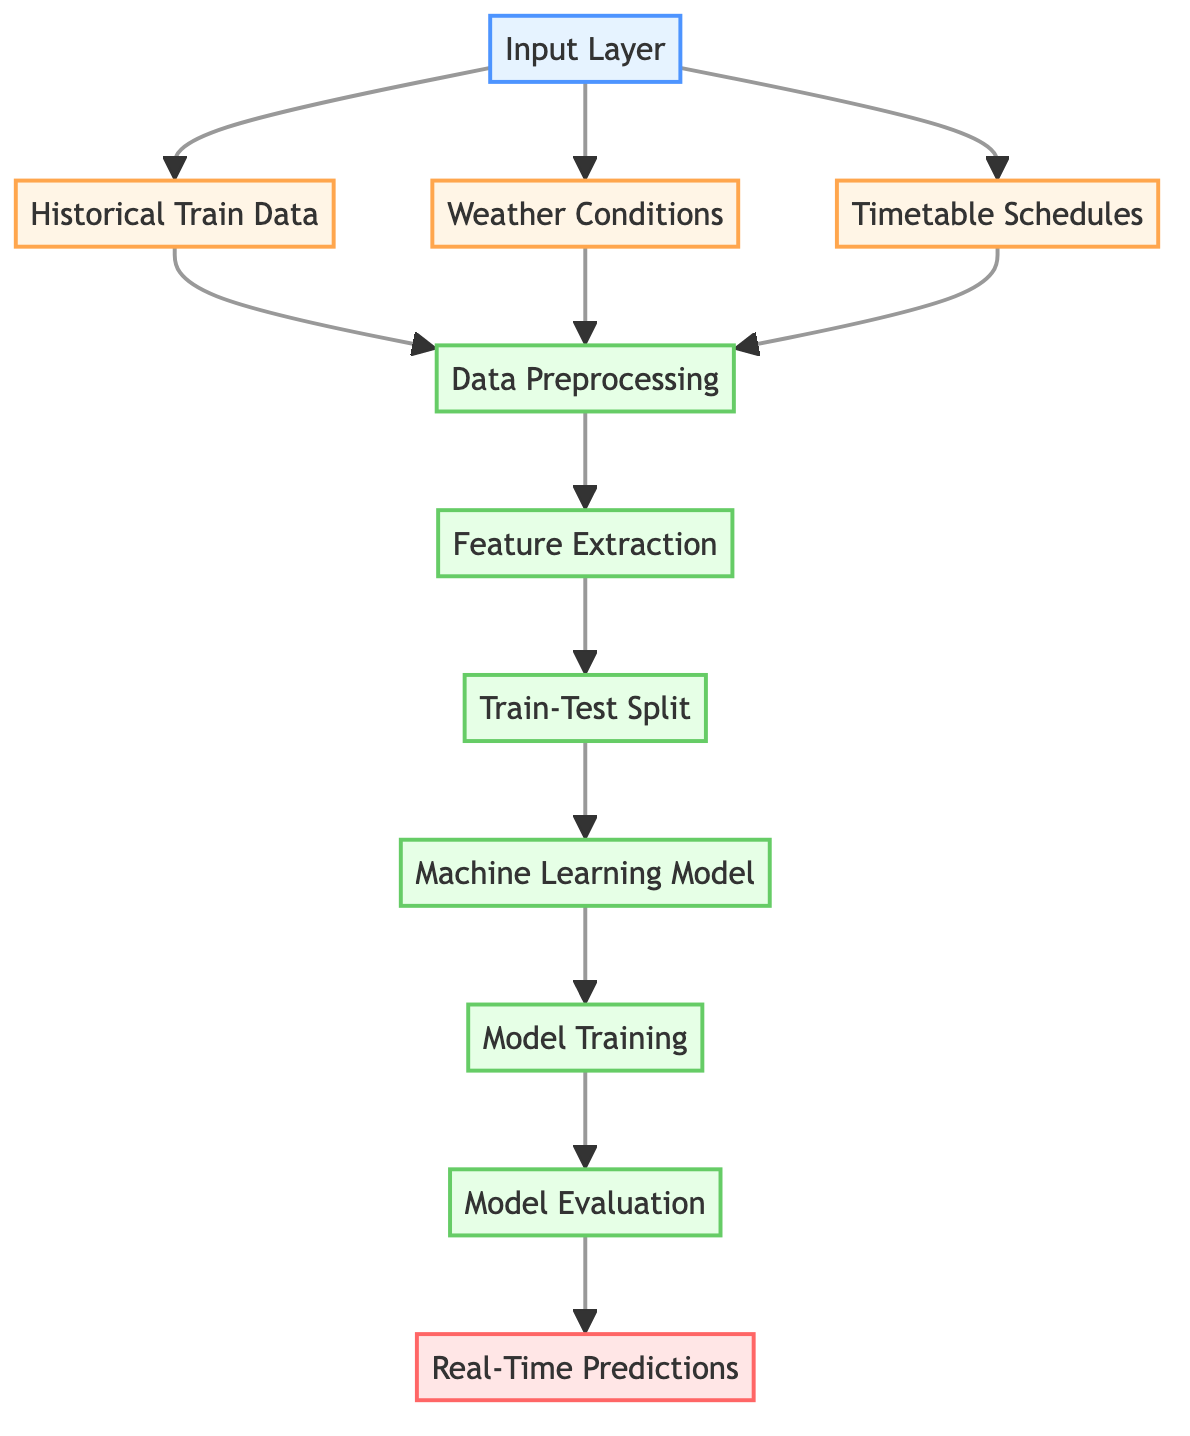What are the three types of input data? The diagram indicates three types of input data on the left side, which are Historical Train Data, Weather Conditions, and Timetable Schedules.
Answer: Historical Train Data, Weather Conditions, Timetable Schedules What does the second step after input data represent? The second step in the diagram, following the input data layer, is Data Preprocessing, which prepares the input data for further analysis and modeling.
Answer: Data Preprocessing How many process nodes are in the diagram? Counting the nodes labeled as process, there are five in total: Data Preprocessing, Feature Extraction, Train-Test Split, Machine Learning Model, and Model Training.
Answer: Five Which node comes just before Real-Time Predictions? The node that directly precedes Real-Time Predictions in the flow of the diagram is Model Evaluation, suggesting that predictions are made after evaluating the model's performance.
Answer: Model Evaluation What is the first node in the machine learning process? The first node in the machine learning process, which indicates the starting point, is Input Layer, where the necessary input data is gathered.
Answer: Input Layer What is the last step after Model Training? The last step in the diagram, following Model Training, is Model Evaluation, which assesses the performance of the trained model before making real-time predictions.
Answer: Model Evaluation How many types of data preprocessing are implied in this diagram? The diagram does not detail the specific methods used for data preprocessing but indicates that this step is foundational before proceeding to feature extraction, so it implies at least one form of data preprocessing is involved.
Answer: One Which input data types are combined before data preprocessing? The input data types that are combined before passing on to data preprocessing are Historical Train Data, Weather Conditions, and Timetable Schedules, indicating their collective importance.
Answer: Historical Train Data, Weather Conditions, Timetable Schedules What is the function of the Machine Learning Model node? The Machine Learning Model node represents the phase where the prepared data is utilized to create a predictive model, enabling the forecast of train traffic.
Answer: Predictive model creation 